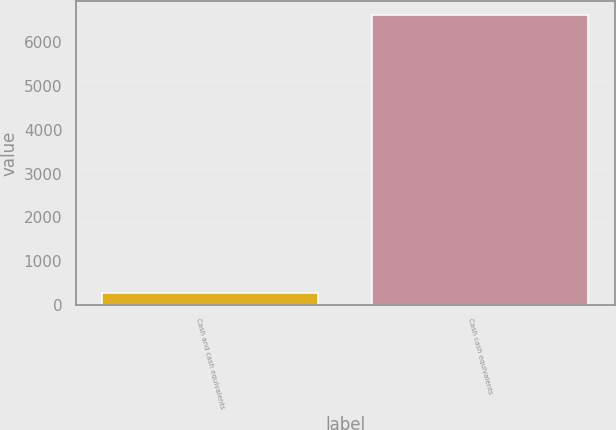Convert chart to OTSL. <chart><loc_0><loc_0><loc_500><loc_500><bar_chart><fcel>Cash and cash equivalents<fcel>Cash cash equivalents<nl><fcel>257<fcel>6617.6<nl></chart> 